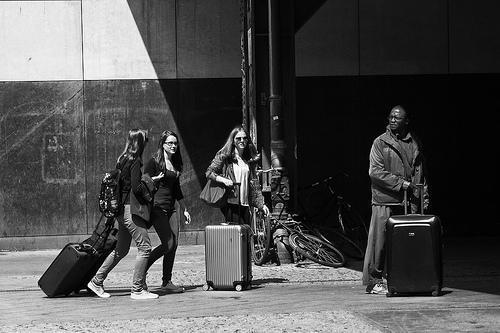How many girls are rolling a suitcase?
Give a very brief answer. 1. 